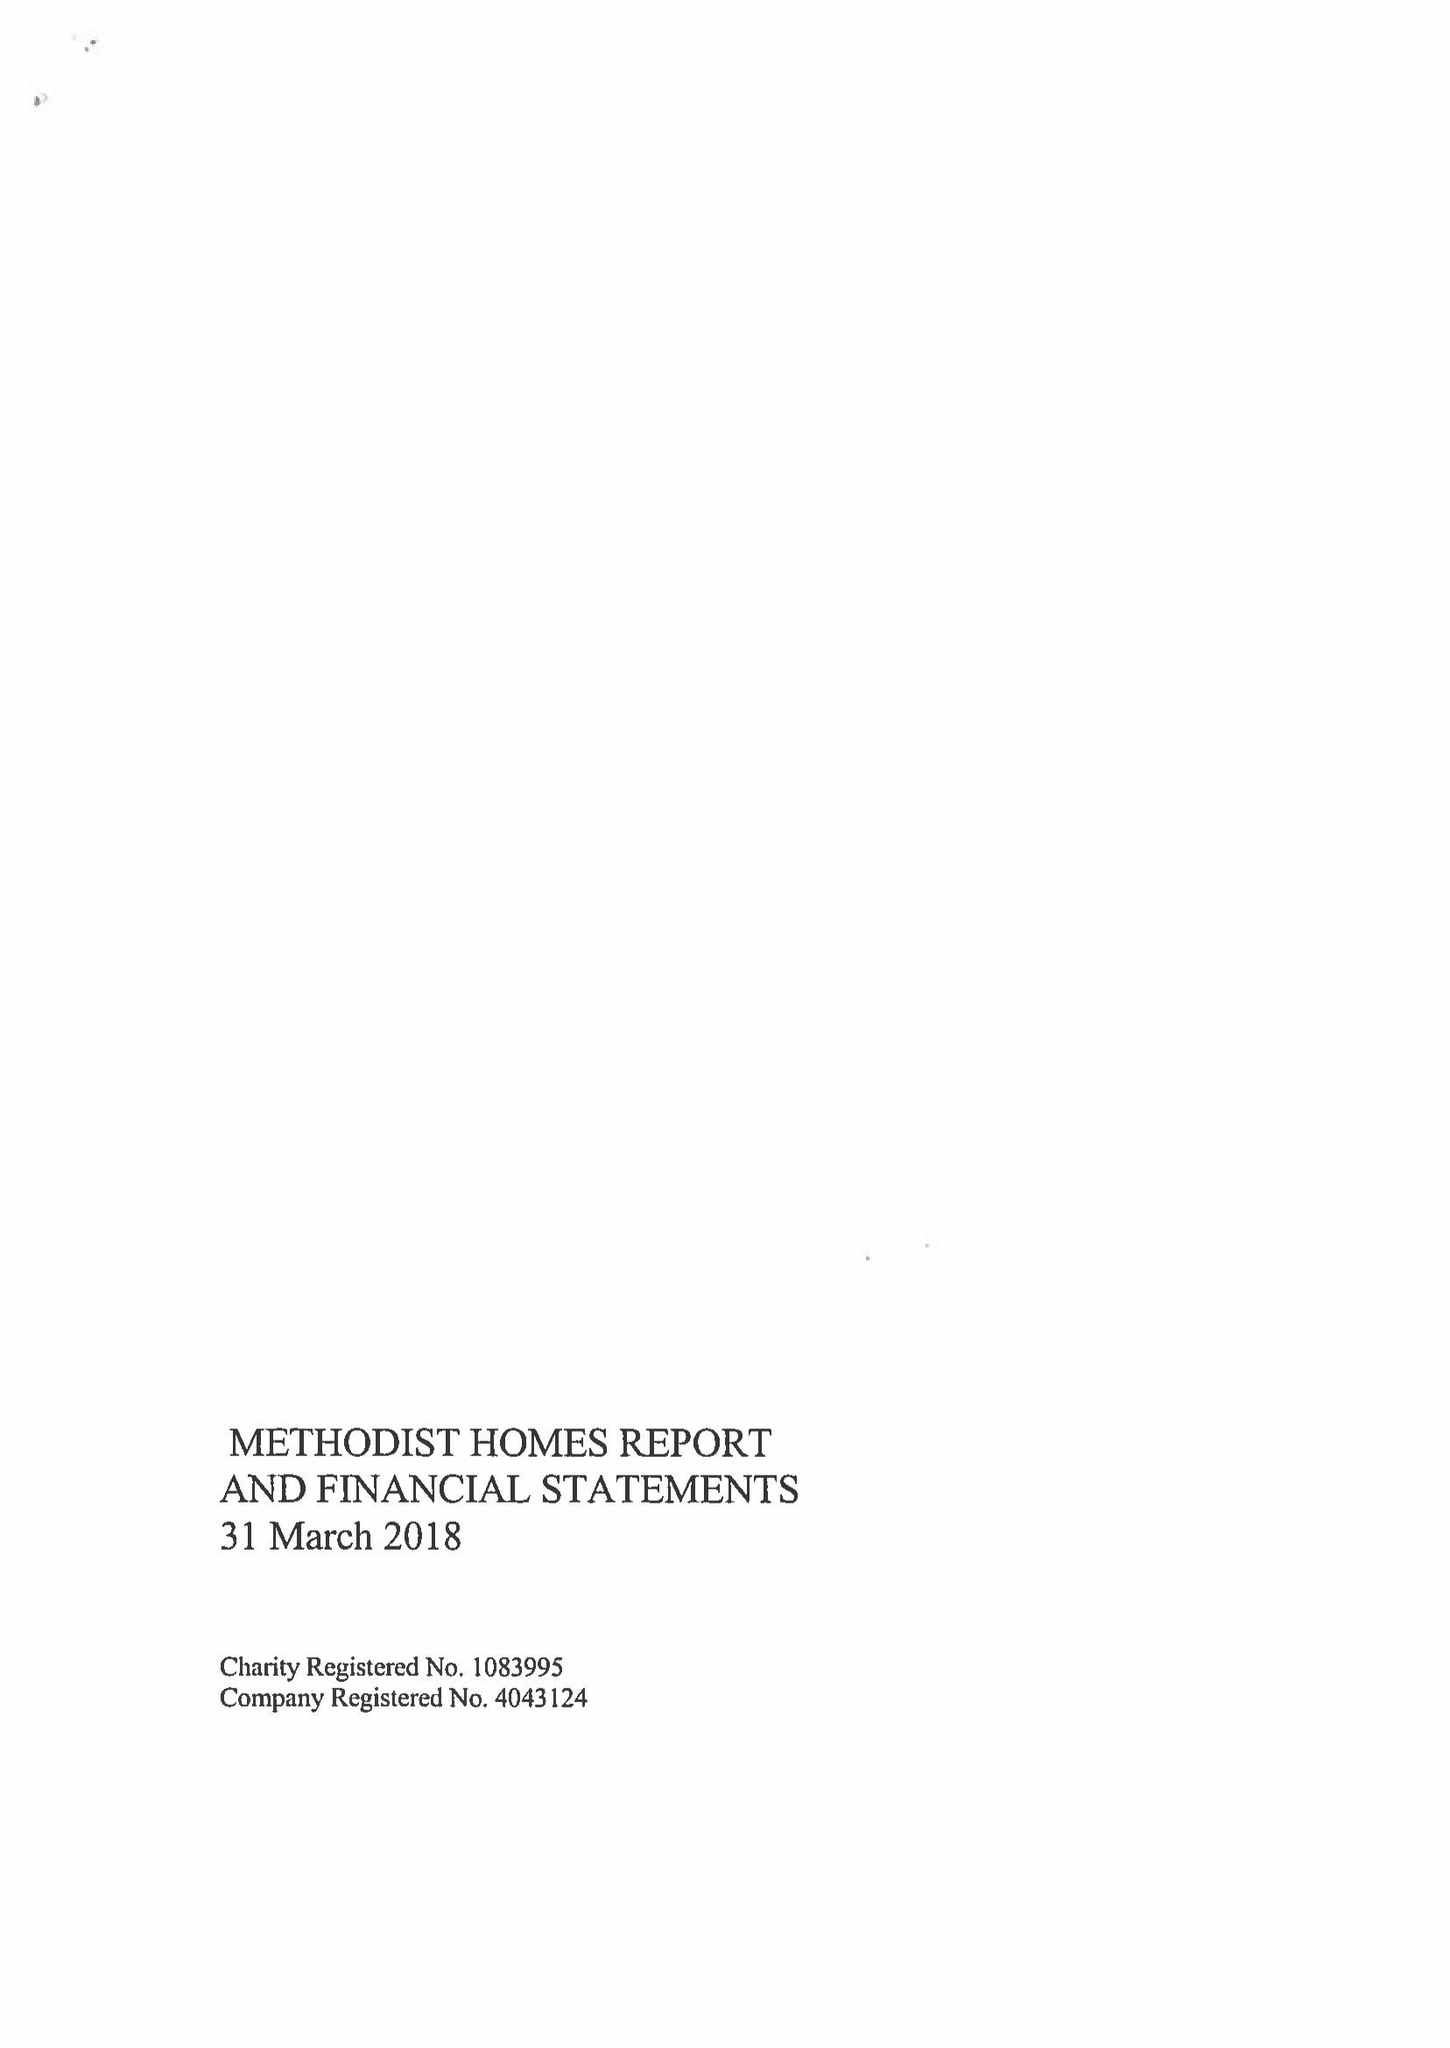What is the value for the charity_name?
Answer the question using a single word or phrase. Methodist Homes 